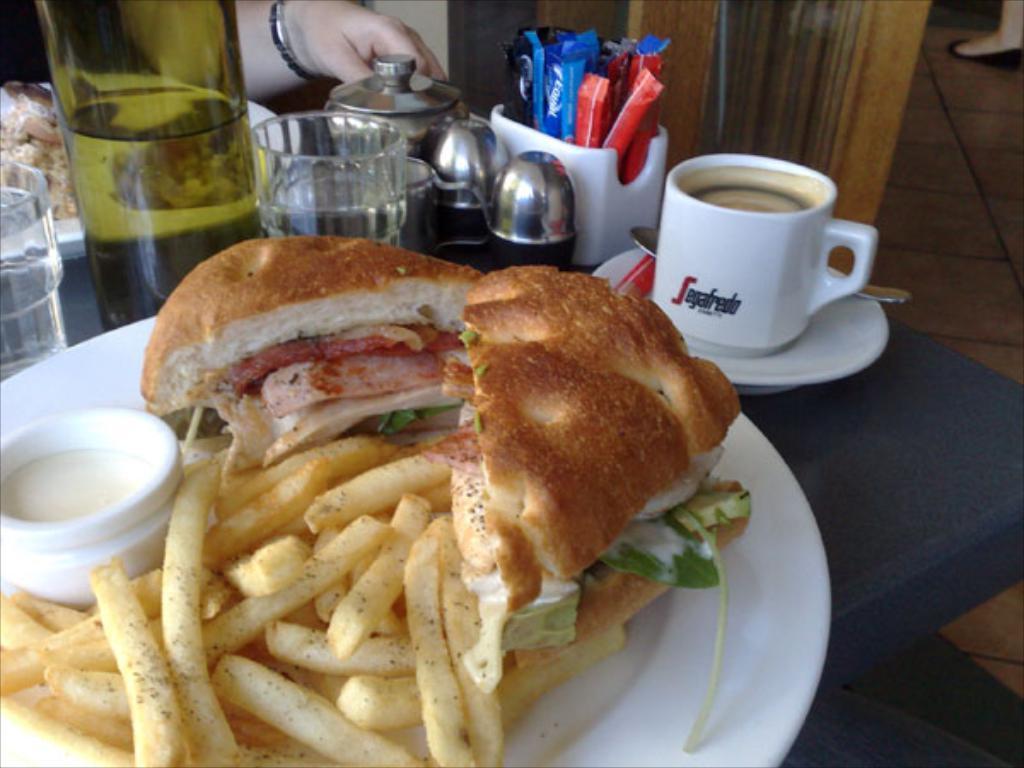Can you describe this image briefly? In this picture we can see plates, food, fries, cup, saucer, glasses, holder, bottle and objects on the table. We can see person's hand. In the background of the image we can see floor and person's leg with footwear. 